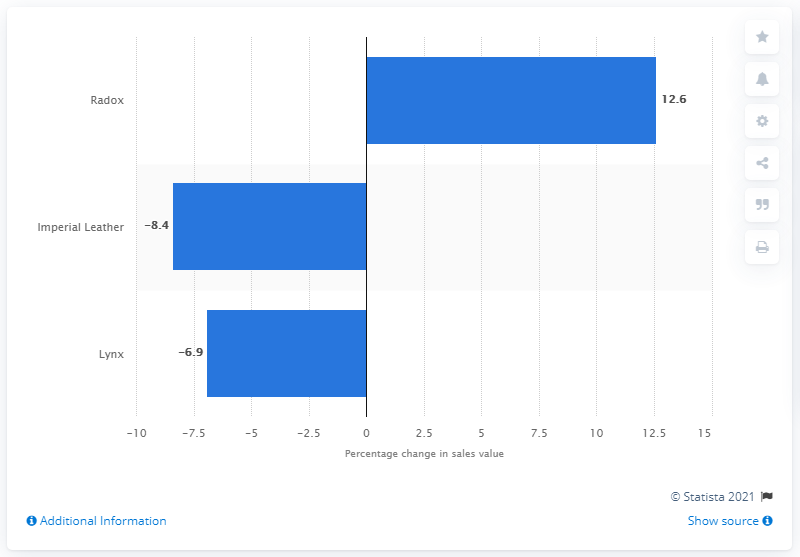List a handful of essential elements in this visual. Radox has successfully achieved positive sales growth during the specified time period, making it the brand that has managed to maintain positive sales growth. 